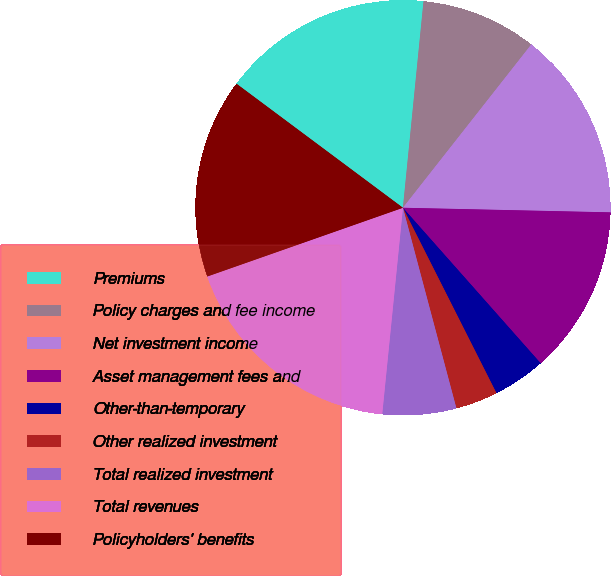Convert chart. <chart><loc_0><loc_0><loc_500><loc_500><pie_chart><fcel>Premiums<fcel>Policy charges and fee income<fcel>Net investment income<fcel>Asset management fees and<fcel>Other-than-temporary<fcel>Other realized investment<fcel>Total realized investment<fcel>Total revenues<fcel>Policyholders' benefits<nl><fcel>16.39%<fcel>9.02%<fcel>14.75%<fcel>13.11%<fcel>4.1%<fcel>3.29%<fcel>5.74%<fcel>18.03%<fcel>15.57%<nl></chart> 